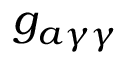Convert formula to latex. <formula><loc_0><loc_0><loc_500><loc_500>g _ { a \gamma \gamma }</formula> 